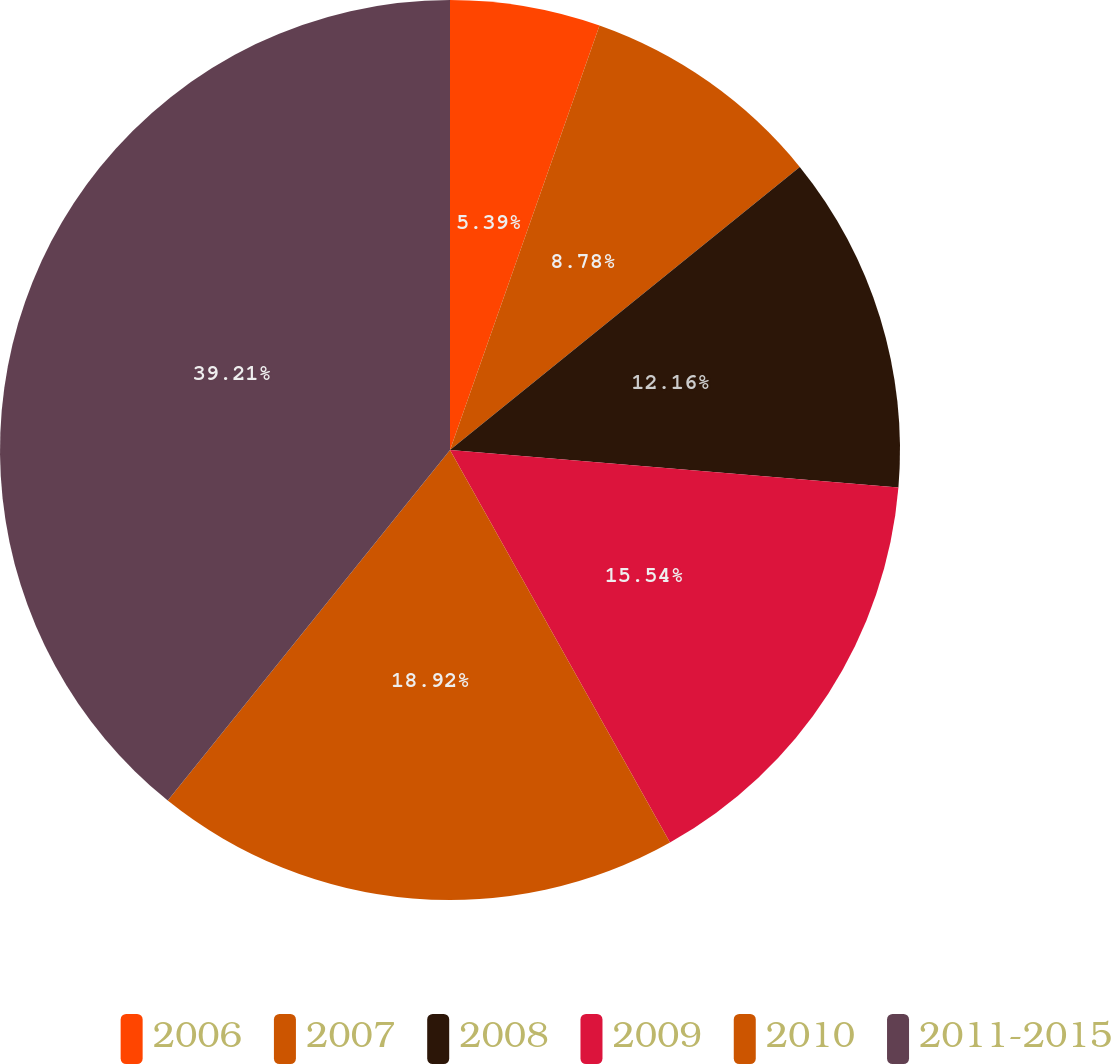Convert chart to OTSL. <chart><loc_0><loc_0><loc_500><loc_500><pie_chart><fcel>2006<fcel>2007<fcel>2008<fcel>2009<fcel>2010<fcel>2011-2015<nl><fcel>5.39%<fcel>8.78%<fcel>12.16%<fcel>15.54%<fcel>18.92%<fcel>39.21%<nl></chart> 